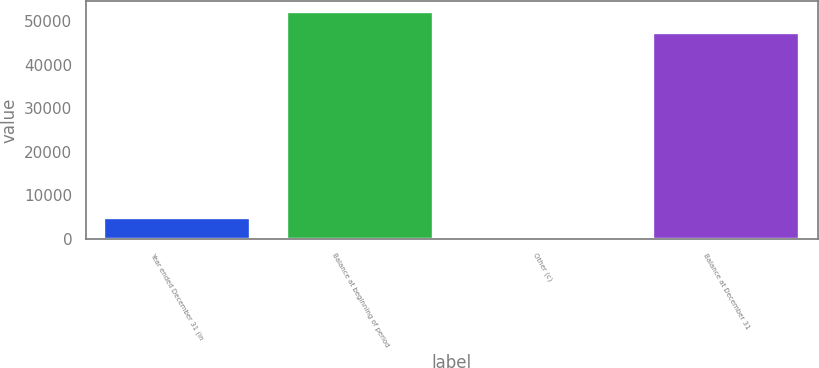Convert chart to OTSL. <chart><loc_0><loc_0><loc_500><loc_500><bar_chart><fcel>Year ended December 31 (in<fcel>Balance at beginning of period<fcel>Other (c)<fcel>Balance at December 31<nl><fcel>4764<fcel>52017<fcel>35<fcel>47288<nl></chart> 